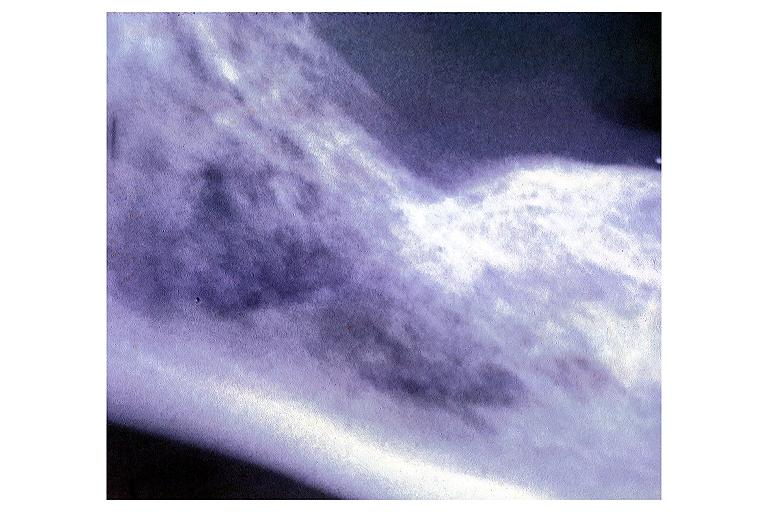what does this image show?
Answer the question using a single word or phrase. Metastatic adenocarcinoma 